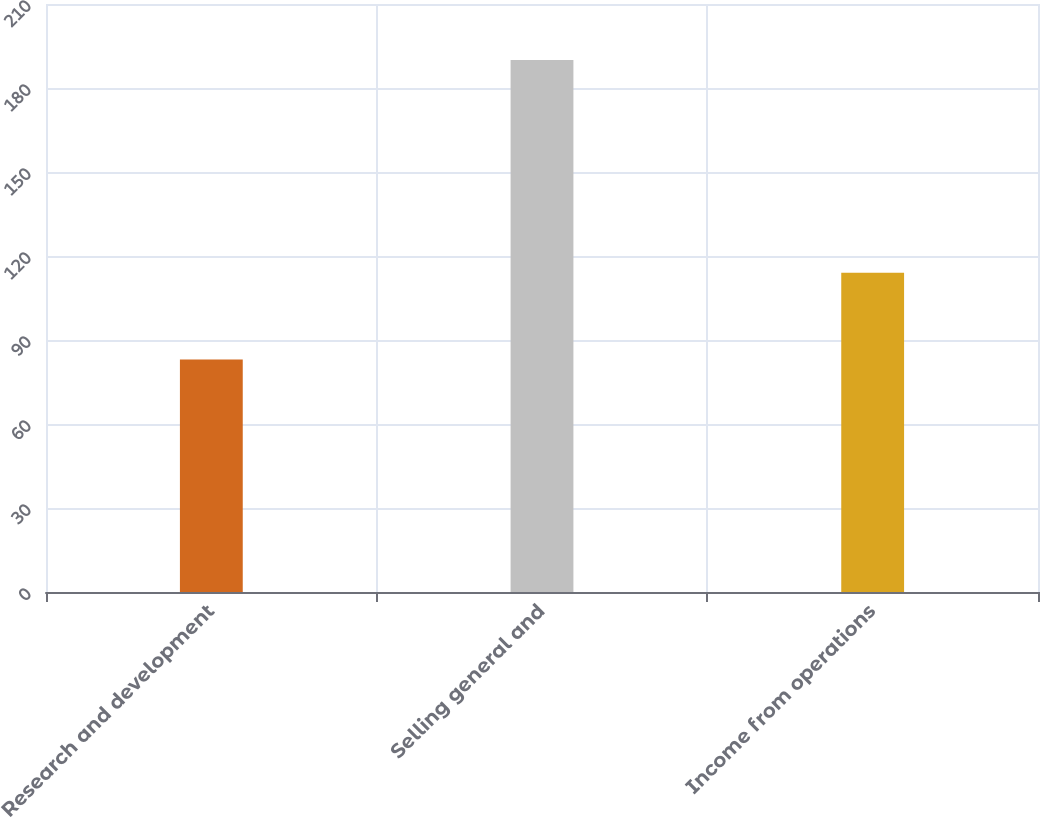<chart> <loc_0><loc_0><loc_500><loc_500><bar_chart><fcel>Research and development<fcel>Selling general and<fcel>Income from operations<nl><fcel>83<fcel>190<fcel>114<nl></chart> 